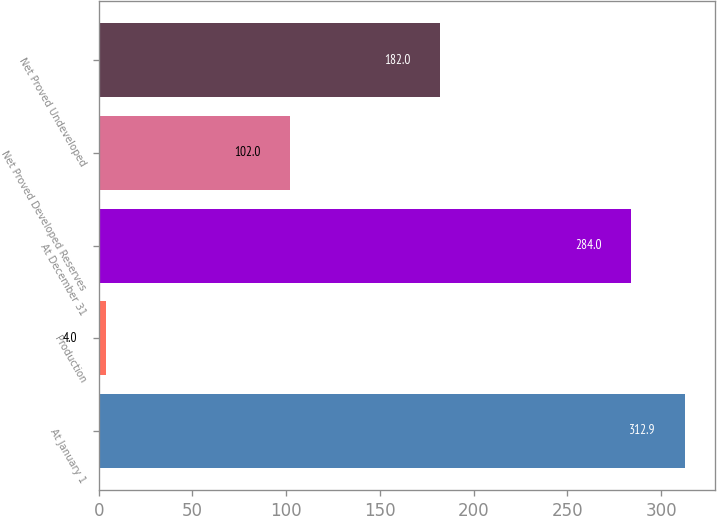<chart> <loc_0><loc_0><loc_500><loc_500><bar_chart><fcel>At January 1<fcel>Production<fcel>At December 31<fcel>Net Proved Developed Reserves<fcel>Net Proved Undeveloped<nl><fcel>312.9<fcel>4<fcel>284<fcel>102<fcel>182<nl></chart> 